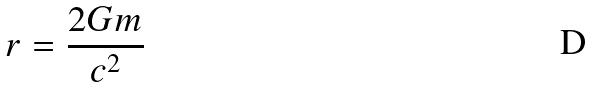Convert formula to latex. <formula><loc_0><loc_0><loc_500><loc_500>r = \frac { 2 G m } { c ^ { 2 } }</formula> 